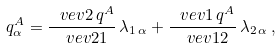<formula> <loc_0><loc_0><loc_500><loc_500>q _ { \alpha } ^ { A } = \frac { \ v e v { 2 \, q ^ { A } } } { \ v e v { 2 1 } } \, \lambda _ { 1 \, \alpha } + \frac { \ v e v { 1 \, q ^ { A } } } { \ v e v { 1 2 } } \, \lambda _ { 2 \, \alpha } \, ,</formula> 